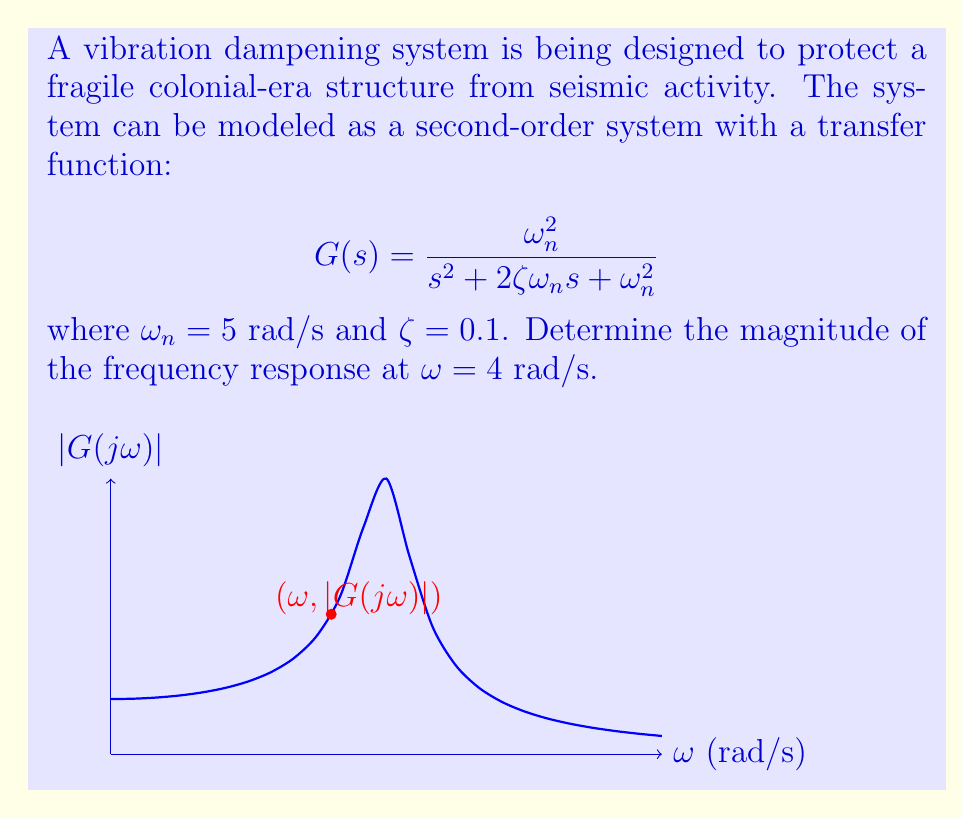Could you help me with this problem? To evaluate the frequency response magnitude at $\omega = 4$ rad/s, we follow these steps:

1) The frequency response is obtained by substituting $s$ with $j\omega$ in the transfer function:

   $$G(j\omega) = \frac{\omega_n^2}{(j\omega)^2 + 2\zeta\omega_n(j\omega) + \omega_n^2}$$

2) Substitute the given values: $\omega_n = 5$ rad/s, $\zeta = 0.1$, and $\omega = 4$ rad/s:

   $$G(j4) = \frac{5^2}{(j4)^2 + 2(0.1)(5)(j4) + 5^2}$$

3) Simplify:

   $$G(j4) = \frac{25}{-16 + j4 + 25} = \frac{25}{9 + j4}$$

4) The magnitude of the frequency response is given by:

   $$|G(j\omega)| = \frac{|\omega_n^2|}{\sqrt{(\omega_n^2 - \omega^2)^2 + (2\zeta\omega_n\omega)^2}}$$

5) Substitute the values:

   $$|G(j4)| = \frac{25}{\sqrt{(25 - 16)^2 + (2 \cdot 0.1 \cdot 5 \cdot 4)^2}}$$

6) Calculate:

   $$|G(j4)| = \frac{25}{\sqrt{81 + 16}} = \frac{25}{\sqrt{97}} \approx 2.54$$

Thus, the magnitude of the frequency response at $\omega = 4$ rad/s is approximately 2.54.
Answer: 2.54 